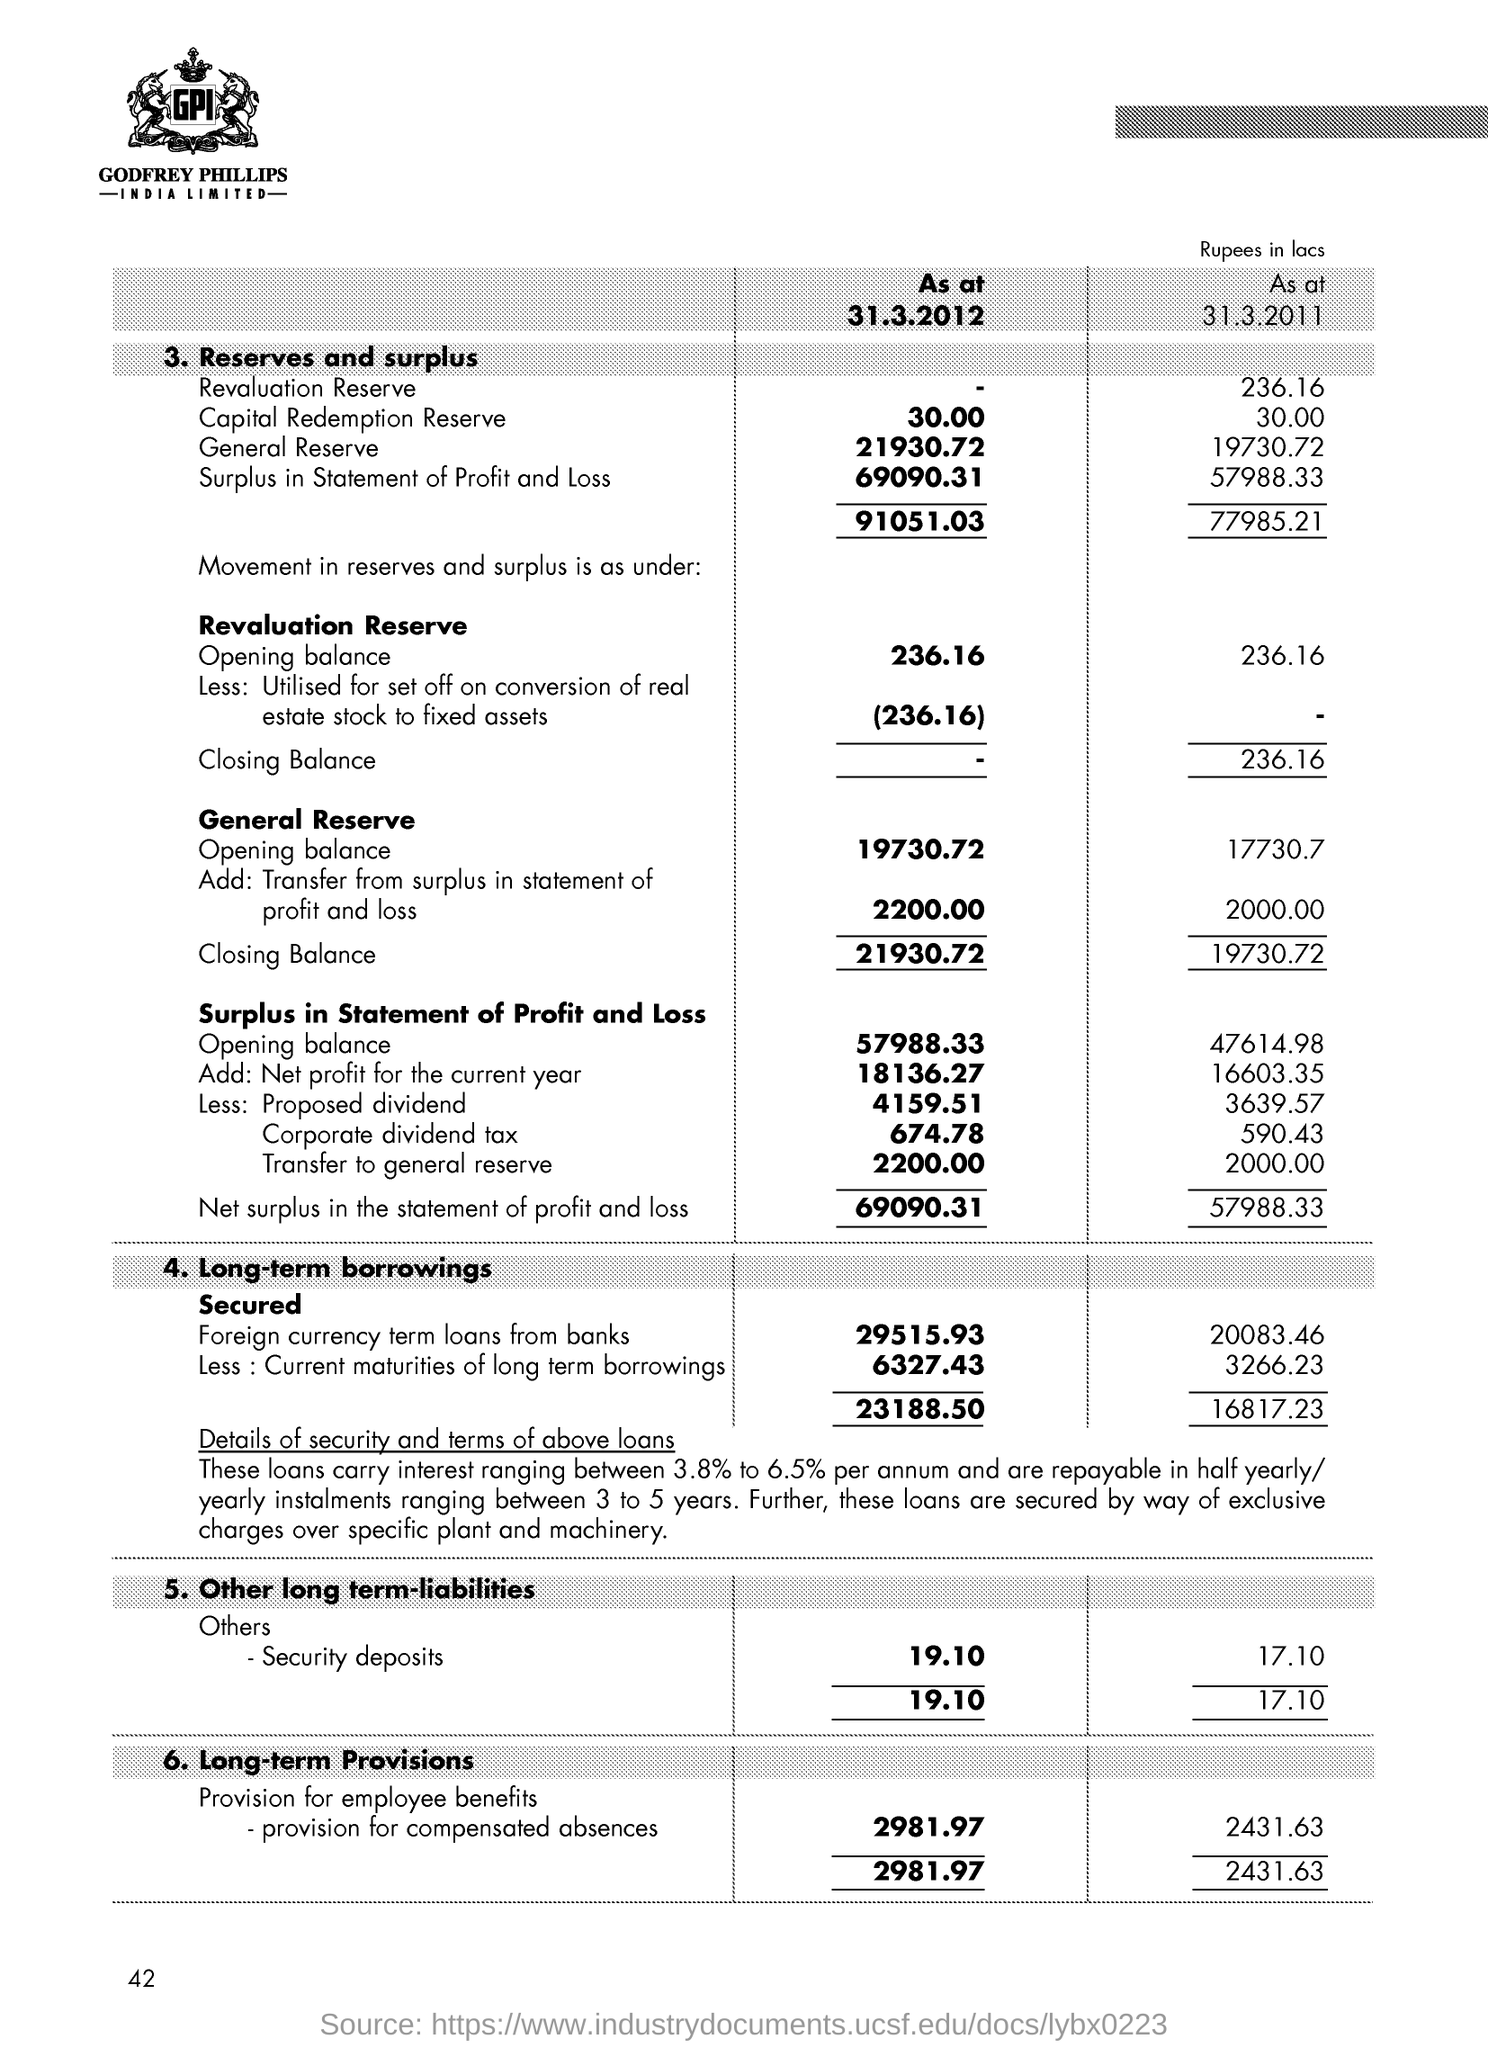Indicate a few pertinent items in this graphic. Loans are secured by way of exclusive charges over plant and machinery. Godfrey Phillips India Limited is the name of the company. 